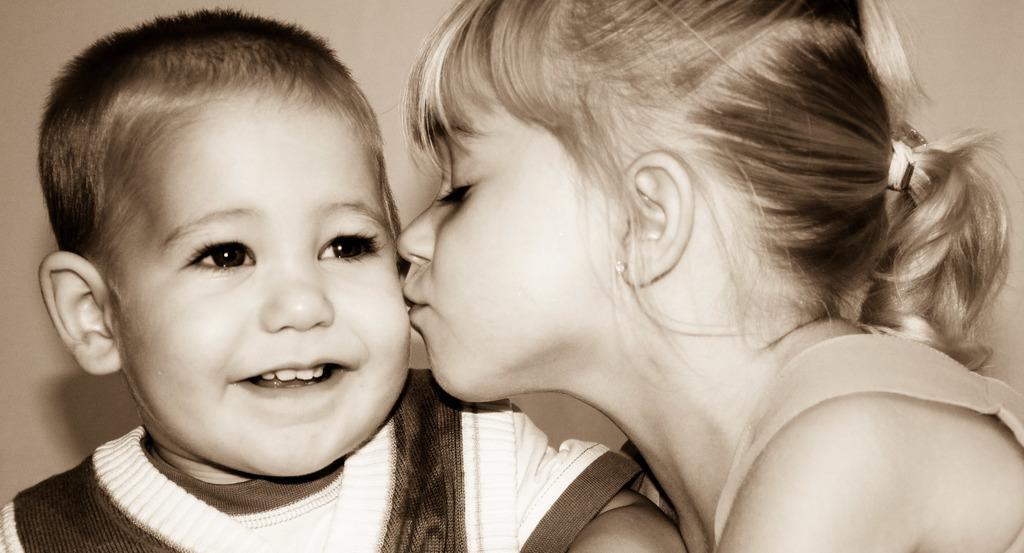Could you give a brief overview of what you see in this image? This image is taken indoors. In the background there is a wall. In the middle of the image there are two kids. A girl is kissing on the cheeks of a boy. 